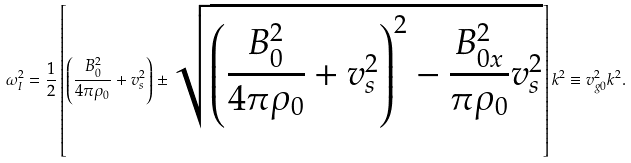<formula> <loc_0><loc_0><loc_500><loc_500>\omega _ { I } ^ { 2 } = \frac { 1 } { 2 } \left [ \left ( \frac { B _ { 0 } ^ { 2 } } { 4 \pi \rho _ { 0 } } + v _ { s } ^ { 2 } \right ) \pm \sqrt { \left ( \frac { B _ { 0 } ^ { 2 } } { 4 \pi \rho _ { 0 } } + v _ { s } ^ { 2 } \right ) ^ { 2 } - \frac { B _ { 0 x } ^ { 2 } } { \pi \rho _ { 0 } } v _ { s } ^ { 2 } } \right ] k ^ { 2 } \equiv v _ { g 0 } ^ { 2 } k ^ { 2 } .</formula> 